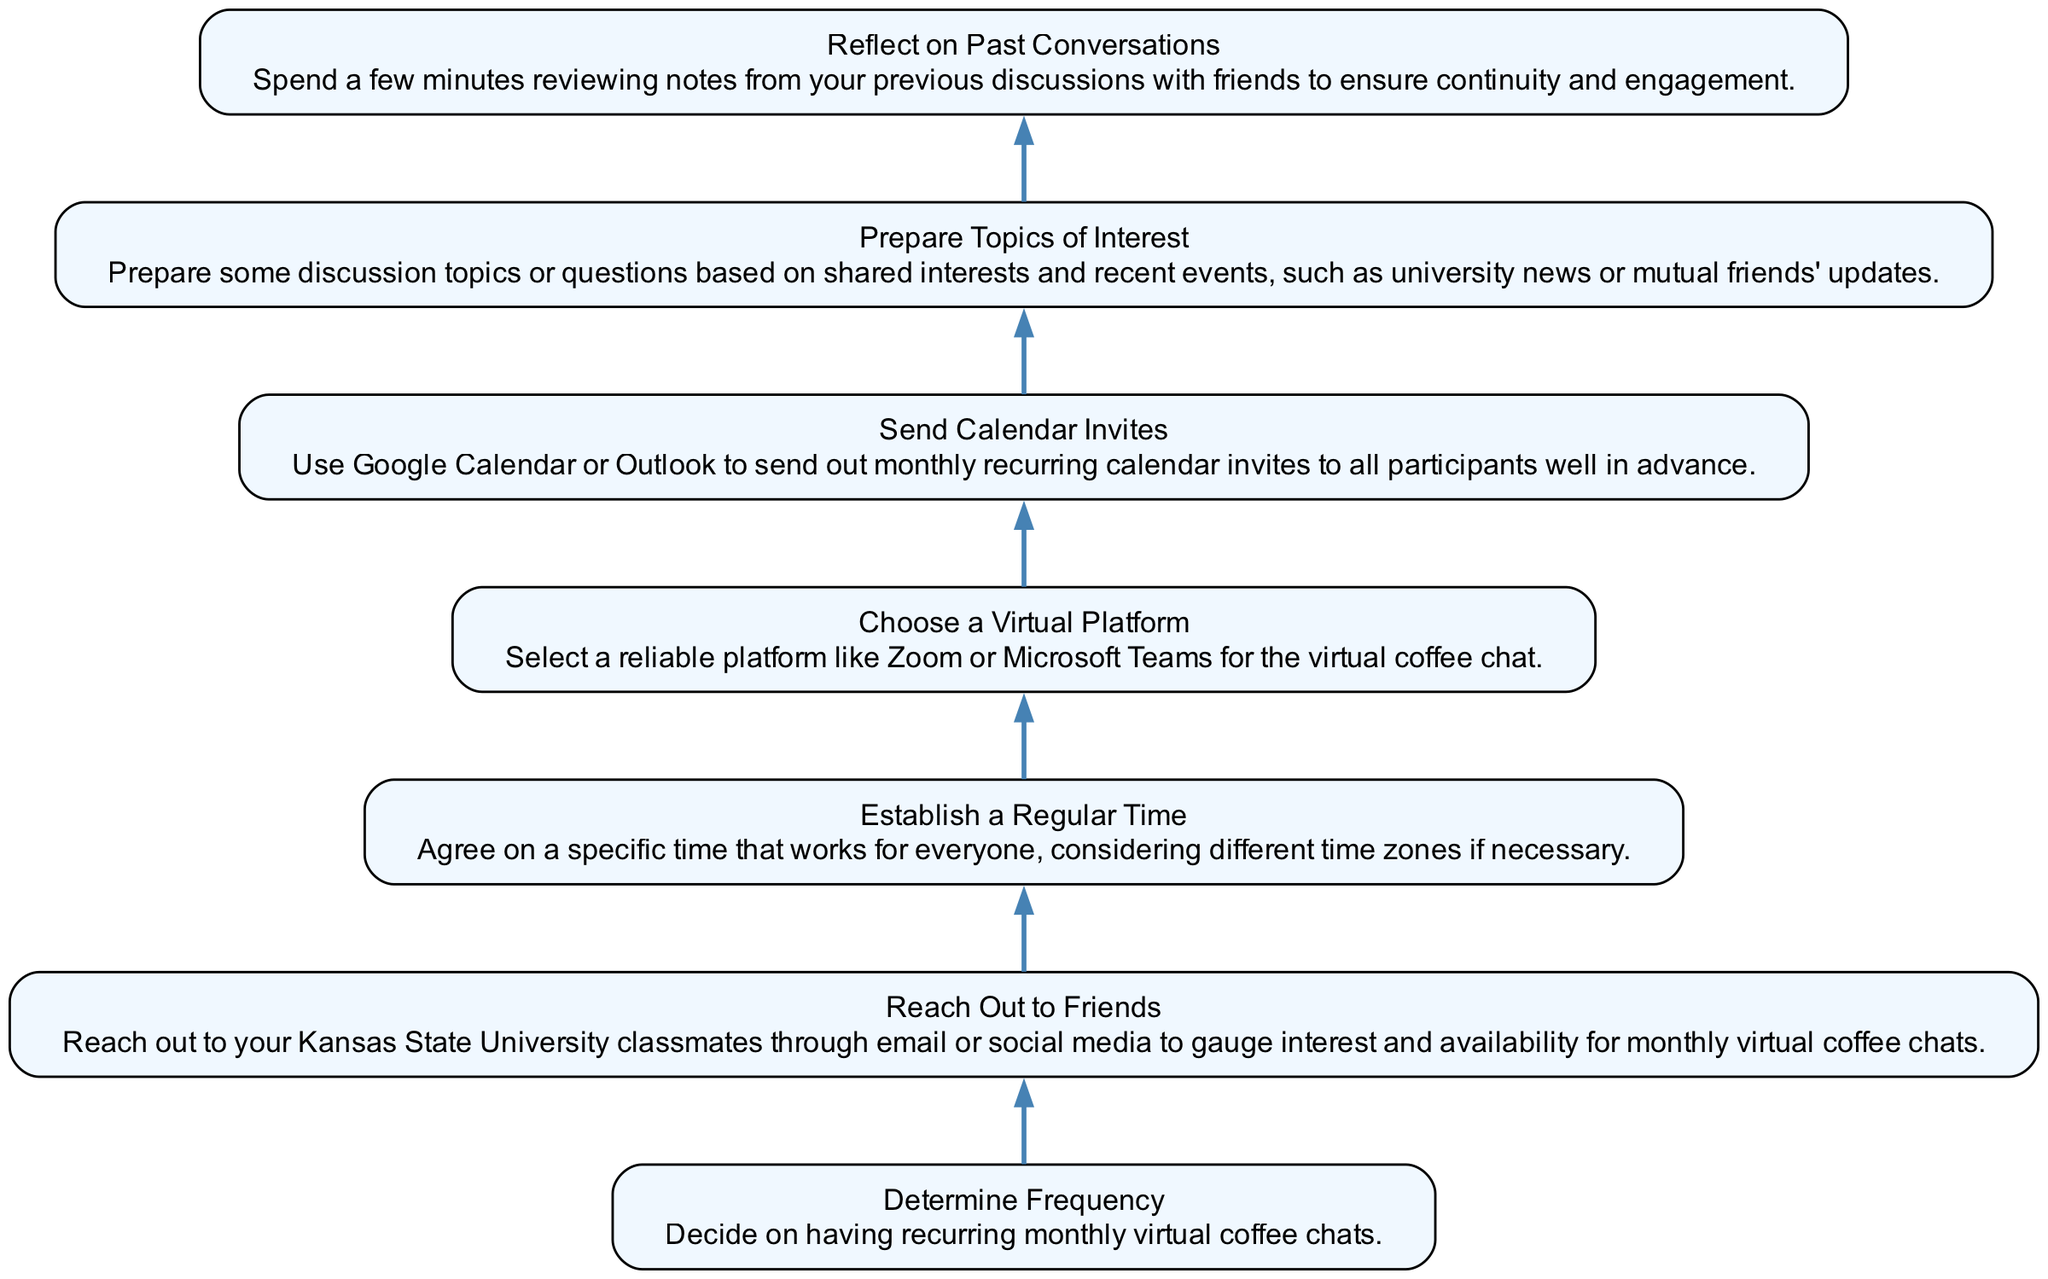What is the first step in setting up monthly virtual coffee chats? The first step is to "Reflect on Past Conversations," as it is the bottom node in the flow chart and serves as the initial action to take.
Answer: Reflect on Past Conversations How many main steps are outlined in the flow chart? The flow chart presents a total of seven main steps, as indicated by the seven nodes listed in the diagram.
Answer: 7 Which step involves deciding on the regularity of the chats? The step that involves deciding on the regularity of the chats is "Determine Frequency," as it emphasizes establishing how often the chats will occur.
Answer: Determine Frequency What action should be taken after preparing topics of interest? After preparing topics of interest, the next action in the chart is to "Send Calendar Invites," indicating the progression of steps needed for implementation.
Answer: Send Calendar Invites How is the “Establish a Regular Time” connected to the previous step? "Establish a Regular Time" follows directly after "Send Calendar Invites" in the flowchart, indicating that after invites are sent, a time agreement must be made.
Answer: Establish a Regular Time Which step comes immediately before “Choose a Virtual Platform”? The step that comes immediately before “Choose a Virtual Platform” is "Establish a Regular Time," illustrating the sequence of required actions in setting up the chats.
Answer: Establish a Regular Time What should be prepared concurrently with sending calendar invites? "Prepare Topics of Interest" should be prepared concurrently since it logically aligns with ensuring participants have engaging discussion points when the invites go out.
Answer: Prepare Topics of Interest What is the purpose of "Reach Out to Friends"? The purpose of "Reach Out to Friends" is to gauge interest and availability, which is essential for planning the virtual coffee chats effectively.
Answer: Gauge interest and availability Which entities are involved in setting up the chats, as inferred from the flow? The primary entities involved are friends from Kansas State University, as these are the participants targeted for the virtual coffee chats.
Answer: Friends from Kansas State University 